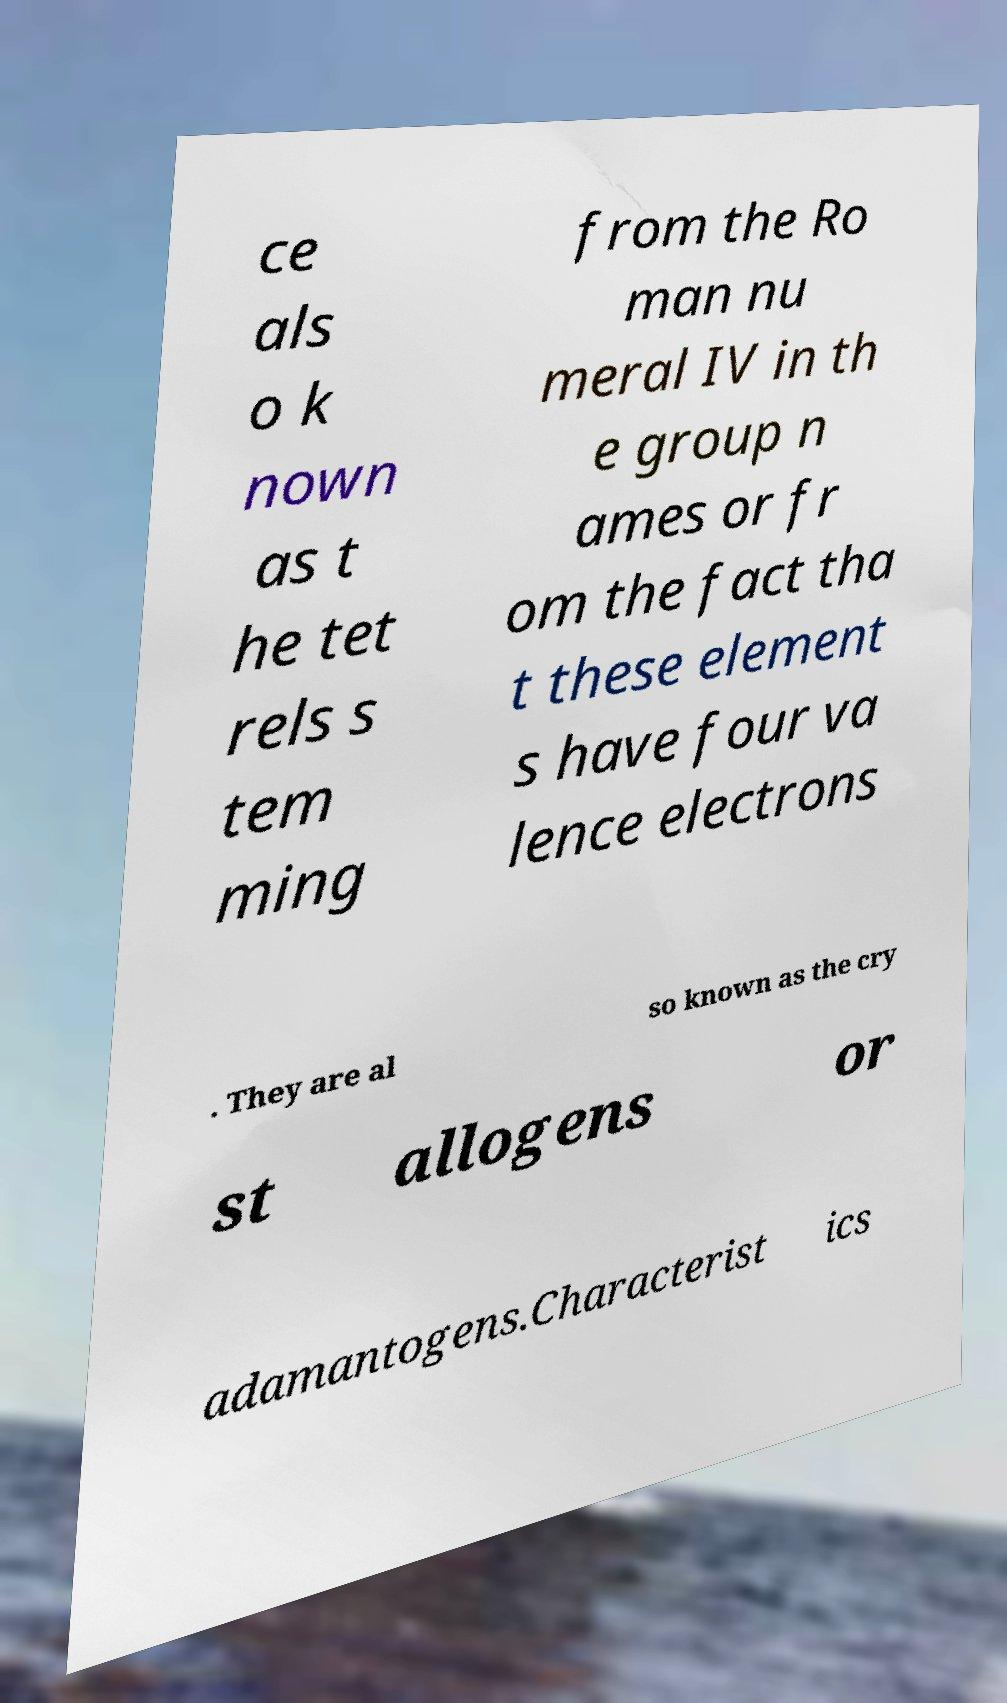Could you assist in decoding the text presented in this image and type it out clearly? ce als o k nown as t he tet rels s tem ming from the Ro man nu meral IV in th e group n ames or fr om the fact tha t these element s have four va lence electrons . They are al so known as the cry st allogens or adamantogens.Characterist ics 